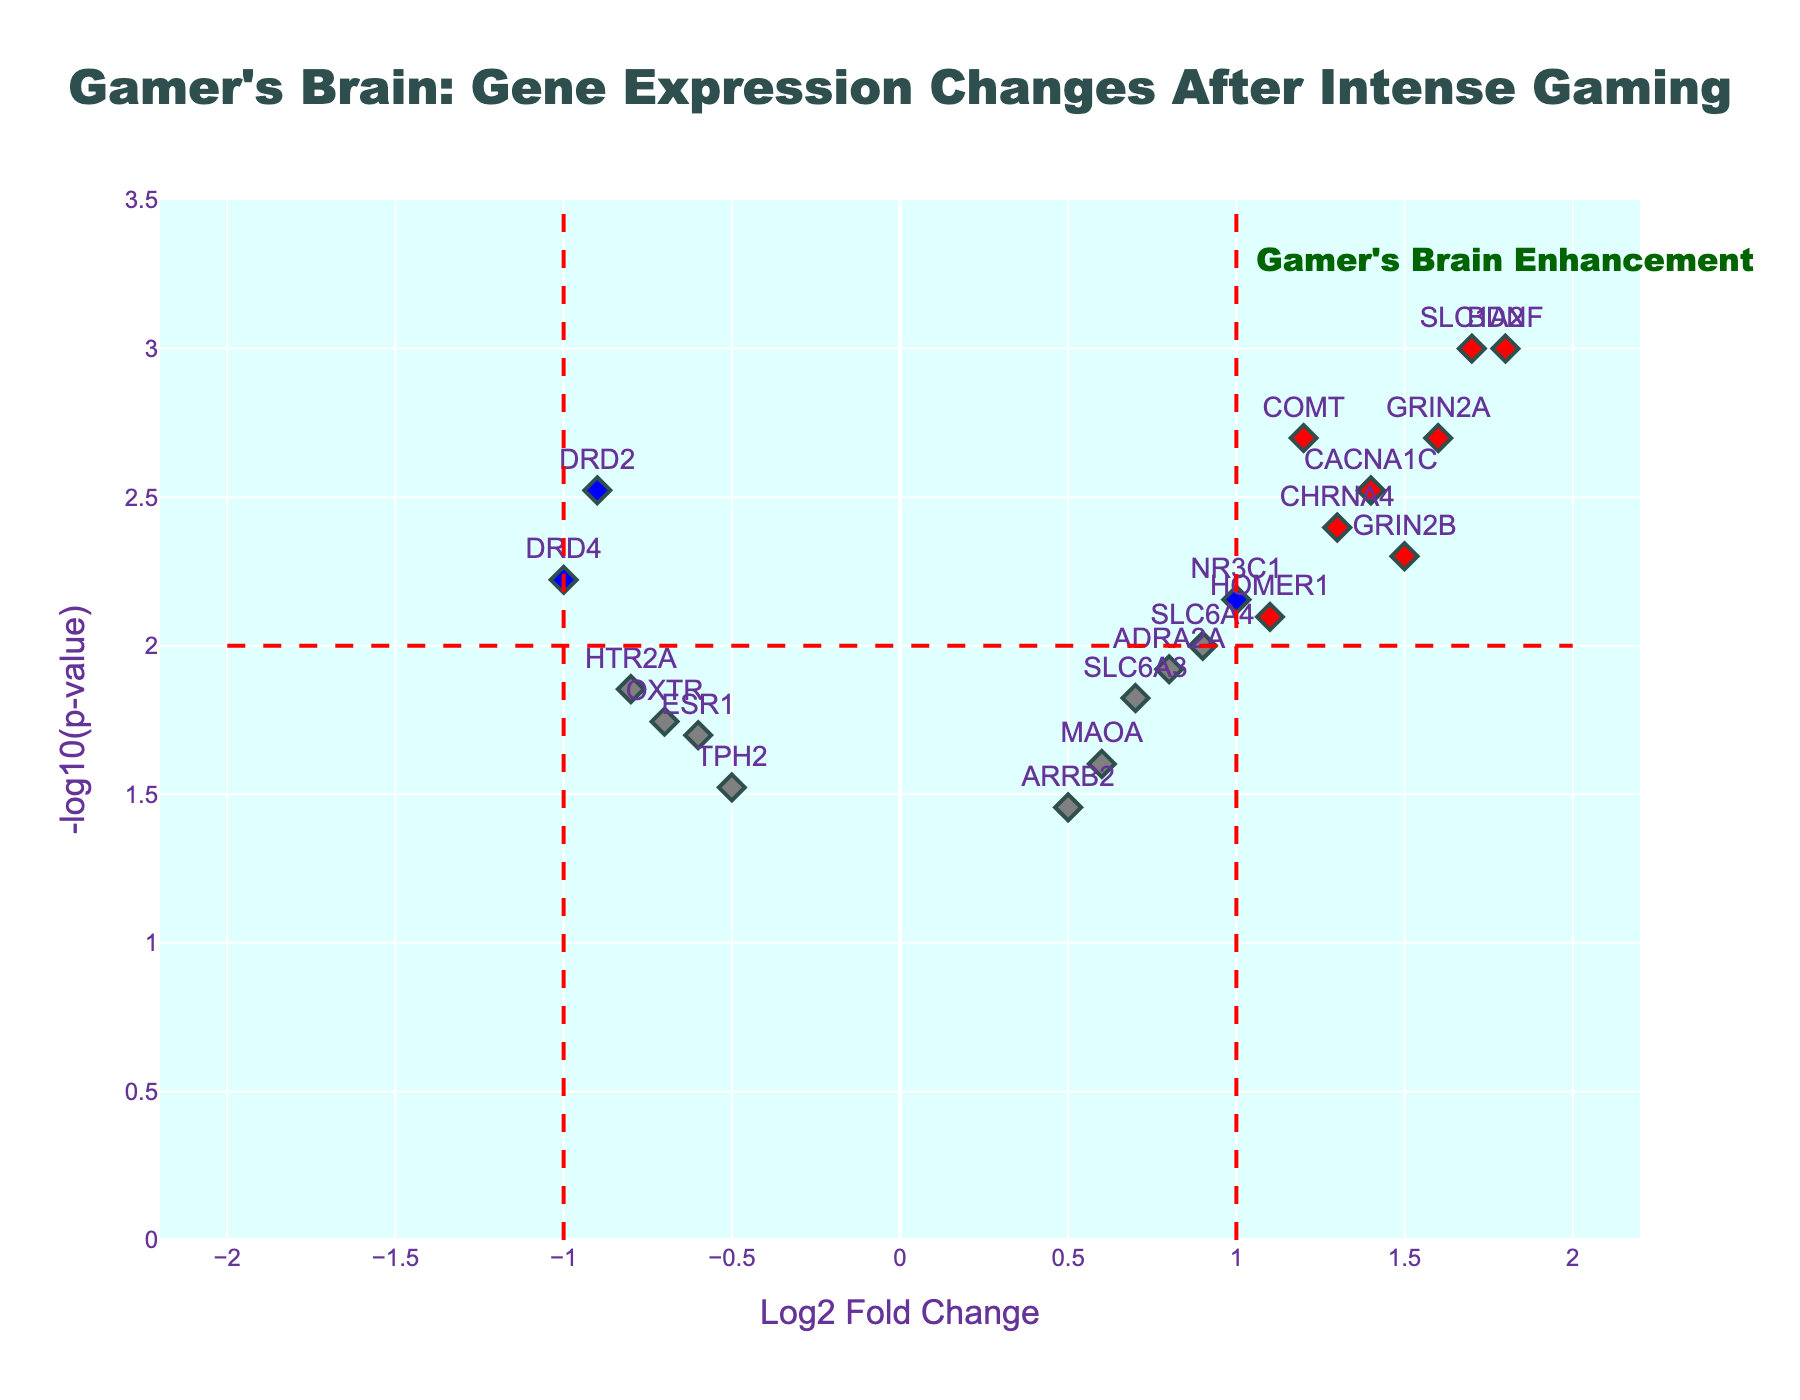Which gene has the highest log2 fold change? Look for the gene with the largest value on the x-axis.
Answer: BDNF What does a red marker represent in the plot? Red markers represent genes with significant changes (log2 fold change > 1 or < -1) and p-value < 0.01.
Answer: Significant changes How many genes have a p-value below 0.01 but log2 fold change less than or equal to 1? Look at the blue markers, as they meet the criteria. Count the blue markers in the plot.
Answer: 4 Which gene has the lowest p-value? Identify the gene with the highest -log10(p-value) on the y-axis.
Answer: BDNF How many genes exhibit a negative log2 fold change with p-value less than 0.01? Highlight green markers on the left side of the plot (negative log2 FC) below the dashed p-value line. Count these markers.
Answer: 3 What is the -log10(p-value) of the gene MAOA? Find the y-coordinate of the MAOA marker.
Answer: ~1.6 Which gene shows a significant increase (positive log2 fold change) and is below the red threshold line? Look at the red markers on the right side of the plot above the y-axis threshold line (-log10(p-value) = 2).
Answer: BDNF Identify genes with log2 fold change between -1.0 and 1.0 and p-value less than 0.01. Examine blue markers within the designated x-axis range (between -1 and 1).
Answer: SLC6A3, ADRA2A, SLC6A4, HTR2A How many genes in total are displayed in the plot? Count each gene represented by a marker.
Answer: 17 Which gene exhibited the highest -log10(p-value) for those with log2 fold change greater than 1? Identify the highest y-axis coordinate among markers on the right side with log2 FC > 1.
Answer: BDNF 